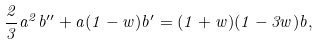Convert formula to latex. <formula><loc_0><loc_0><loc_500><loc_500>\frac { 2 } { 3 } a ^ { 2 } b ^ { \prime \prime } + a ( 1 - w ) b ^ { \prime } = ( 1 + w ) ( 1 - 3 w ) b ,</formula> 